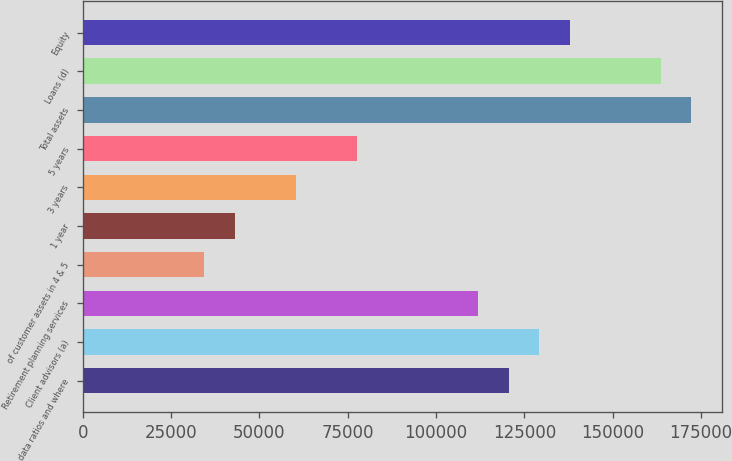<chart> <loc_0><loc_0><loc_500><loc_500><bar_chart><fcel>data ratios and where<fcel>Client advisors (a)<fcel>Retirement planning services<fcel>of customer assets in 4 & 5<fcel>1 year<fcel>3 years<fcel>5 years<fcel>Total assets<fcel>Loans (d)<fcel>Equity<nl><fcel>120534<fcel>129144<fcel>111925<fcel>34438.5<fcel>43048.1<fcel>60267.3<fcel>77486.4<fcel>172192<fcel>163582<fcel>137753<nl></chart> 